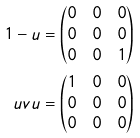<formula> <loc_0><loc_0><loc_500><loc_500>1 - u & = \begin{pmatrix} 0 & 0 & 0 \\ 0 & 0 & 0 \\ 0 & 0 & 1 \\ \end{pmatrix} \\ u v u & = \begin{pmatrix} 1 & 0 & 0 \\ 0 & 0 & 0 \\ 0 & 0 & 0 \\ \end{pmatrix}</formula> 